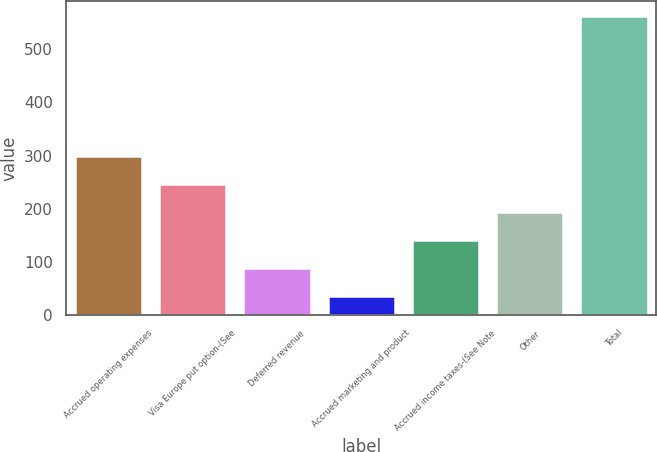Convert chart. <chart><loc_0><loc_0><loc_500><loc_500><bar_chart><fcel>Accrued operating expenses<fcel>Visa Europe put option-(See<fcel>Deferred revenue<fcel>Accrued marketing and product<fcel>Accrued income taxes-(See Note<fcel>Other<fcel>Total<nl><fcel>299<fcel>246.4<fcel>88.6<fcel>36<fcel>141.2<fcel>193.8<fcel>562<nl></chart> 